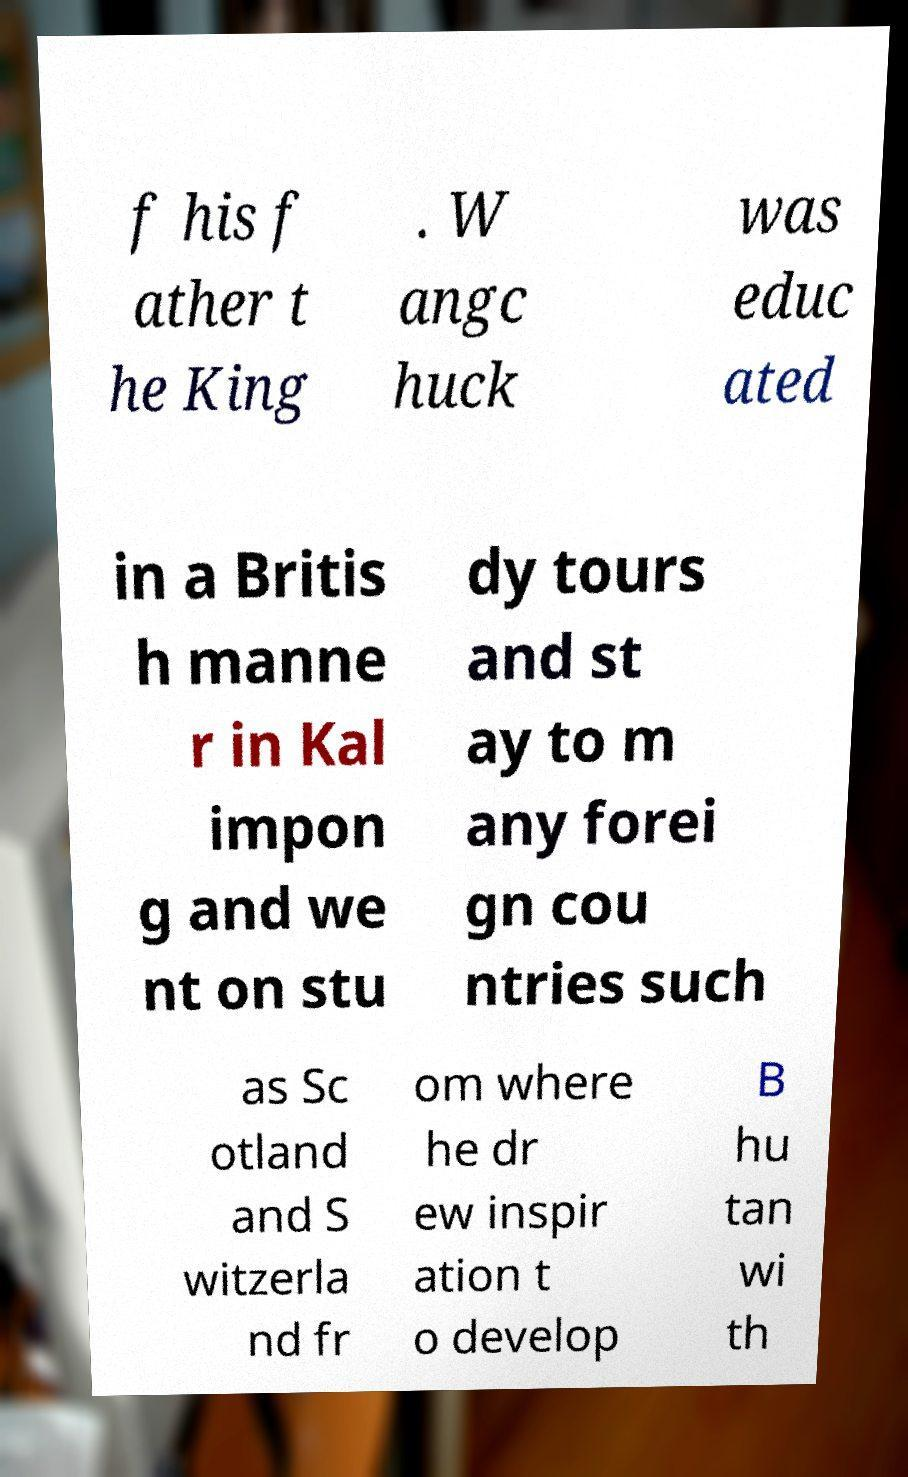Please identify and transcribe the text found in this image. f his f ather t he King . W angc huck was educ ated in a Britis h manne r in Kal impon g and we nt on stu dy tours and st ay to m any forei gn cou ntries such as Sc otland and S witzerla nd fr om where he dr ew inspir ation t o develop B hu tan wi th 